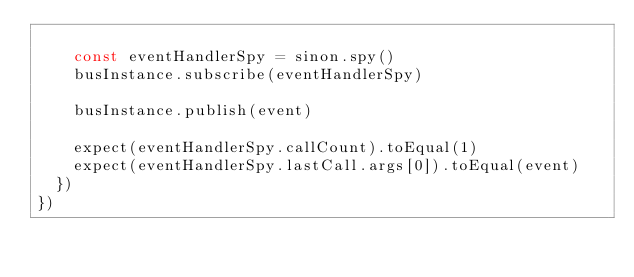Convert code to text. <code><loc_0><loc_0><loc_500><loc_500><_JavaScript_>
    const eventHandlerSpy = sinon.spy()
    busInstance.subscribe(eventHandlerSpy)

    busInstance.publish(event)

    expect(eventHandlerSpy.callCount).toEqual(1)
    expect(eventHandlerSpy.lastCall.args[0]).toEqual(event)
  })
})
</code> 